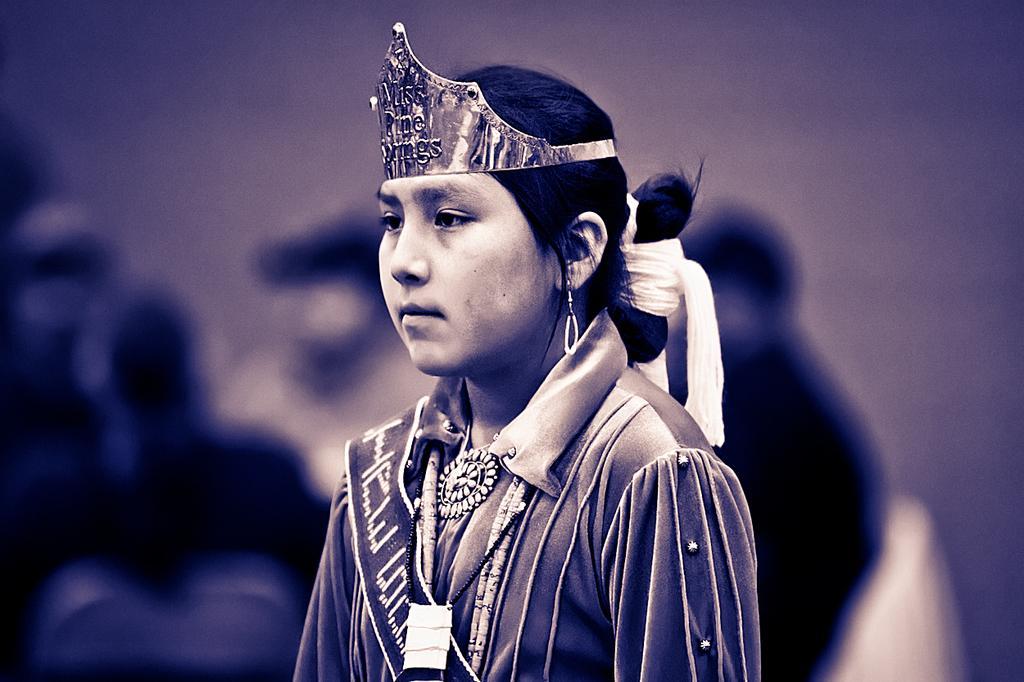In one or two sentences, can you explain what this image depicts? In this picture I can see a girl in front and I see that she is wearing a crown on her head and I see that it is blurred in the background. 